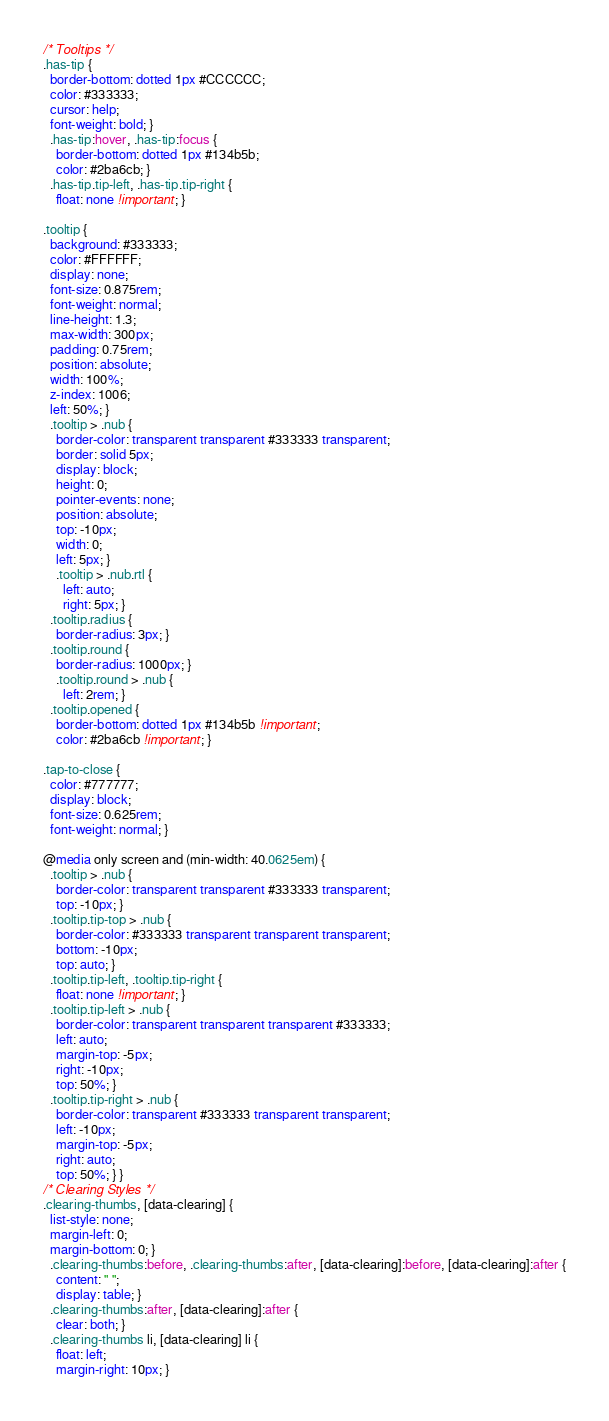<code> <loc_0><loc_0><loc_500><loc_500><_CSS_>
/* Tooltips */
.has-tip {
  border-bottom: dotted 1px #CCCCCC;
  color: #333333;
  cursor: help;
  font-weight: bold; }
  .has-tip:hover, .has-tip:focus {
    border-bottom: dotted 1px #134b5b;
    color: #2ba6cb; }
  .has-tip.tip-left, .has-tip.tip-right {
    float: none !important; }

.tooltip {
  background: #333333;
  color: #FFFFFF;
  display: none;
  font-size: 0.875rem;
  font-weight: normal;
  line-height: 1.3;
  max-width: 300px;
  padding: 0.75rem;
  position: absolute;
  width: 100%;
  z-index: 1006;
  left: 50%; }
  .tooltip > .nub {
    border-color: transparent transparent #333333 transparent;
    border: solid 5px;
    display: block;
    height: 0;
    pointer-events: none;
    position: absolute;
    top: -10px;
    width: 0;
    left: 5px; }
    .tooltip > .nub.rtl {
      left: auto;
      right: 5px; }
  .tooltip.radius {
    border-radius: 3px; }
  .tooltip.round {
    border-radius: 1000px; }
    .tooltip.round > .nub {
      left: 2rem; }
  .tooltip.opened {
    border-bottom: dotted 1px #134b5b !important;
    color: #2ba6cb !important; }

.tap-to-close {
  color: #777777;
  display: block;
  font-size: 0.625rem;
  font-weight: normal; }

@media only screen and (min-width: 40.0625em) {
  .tooltip > .nub {
    border-color: transparent transparent #333333 transparent;
    top: -10px; }
  .tooltip.tip-top > .nub {
    border-color: #333333 transparent transparent transparent;
    bottom: -10px;
    top: auto; }
  .tooltip.tip-left, .tooltip.tip-right {
    float: none !important; }
  .tooltip.tip-left > .nub {
    border-color: transparent transparent transparent #333333;
    left: auto;
    margin-top: -5px;
    right: -10px;
    top: 50%; }
  .tooltip.tip-right > .nub {
    border-color: transparent #333333 transparent transparent;
    left: -10px;
    margin-top: -5px;
    right: auto;
    top: 50%; } }
/* Clearing Styles */
.clearing-thumbs, [data-clearing] {
  list-style: none;
  margin-left: 0;
  margin-bottom: 0; }
  .clearing-thumbs:before, .clearing-thumbs:after, [data-clearing]:before, [data-clearing]:after {
    content: " ";
    display: table; }
  .clearing-thumbs:after, [data-clearing]:after {
    clear: both; }
  .clearing-thumbs li, [data-clearing] li {
    float: left;
    margin-right: 10px; }</code> 